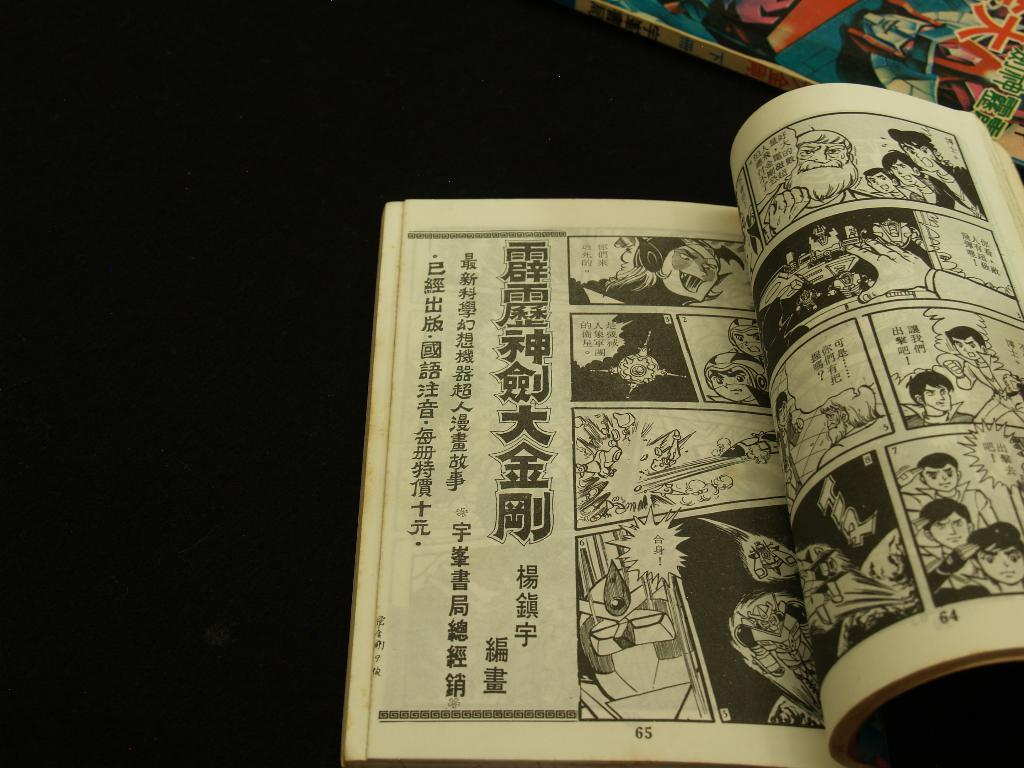<image>
Relay a brief, clear account of the picture shown. The left most page of the book is page 65 